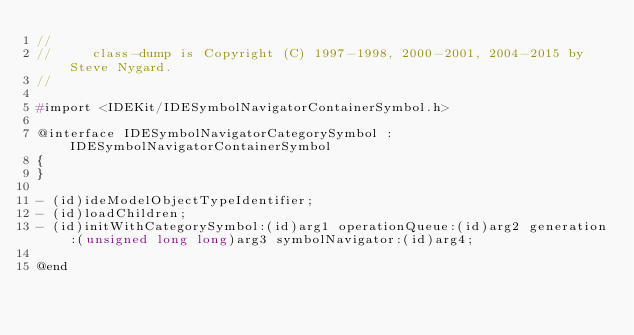Convert code to text. <code><loc_0><loc_0><loc_500><loc_500><_C_>//
//     class-dump is Copyright (C) 1997-1998, 2000-2001, 2004-2015 by Steve Nygard.
//

#import <IDEKit/IDESymbolNavigatorContainerSymbol.h>

@interface IDESymbolNavigatorCategorySymbol : IDESymbolNavigatorContainerSymbol
{
}

- (id)ideModelObjectTypeIdentifier;
- (id)loadChildren;
- (id)initWithCategorySymbol:(id)arg1 operationQueue:(id)arg2 generation:(unsigned long long)arg3 symbolNavigator:(id)arg4;

@end

</code> 